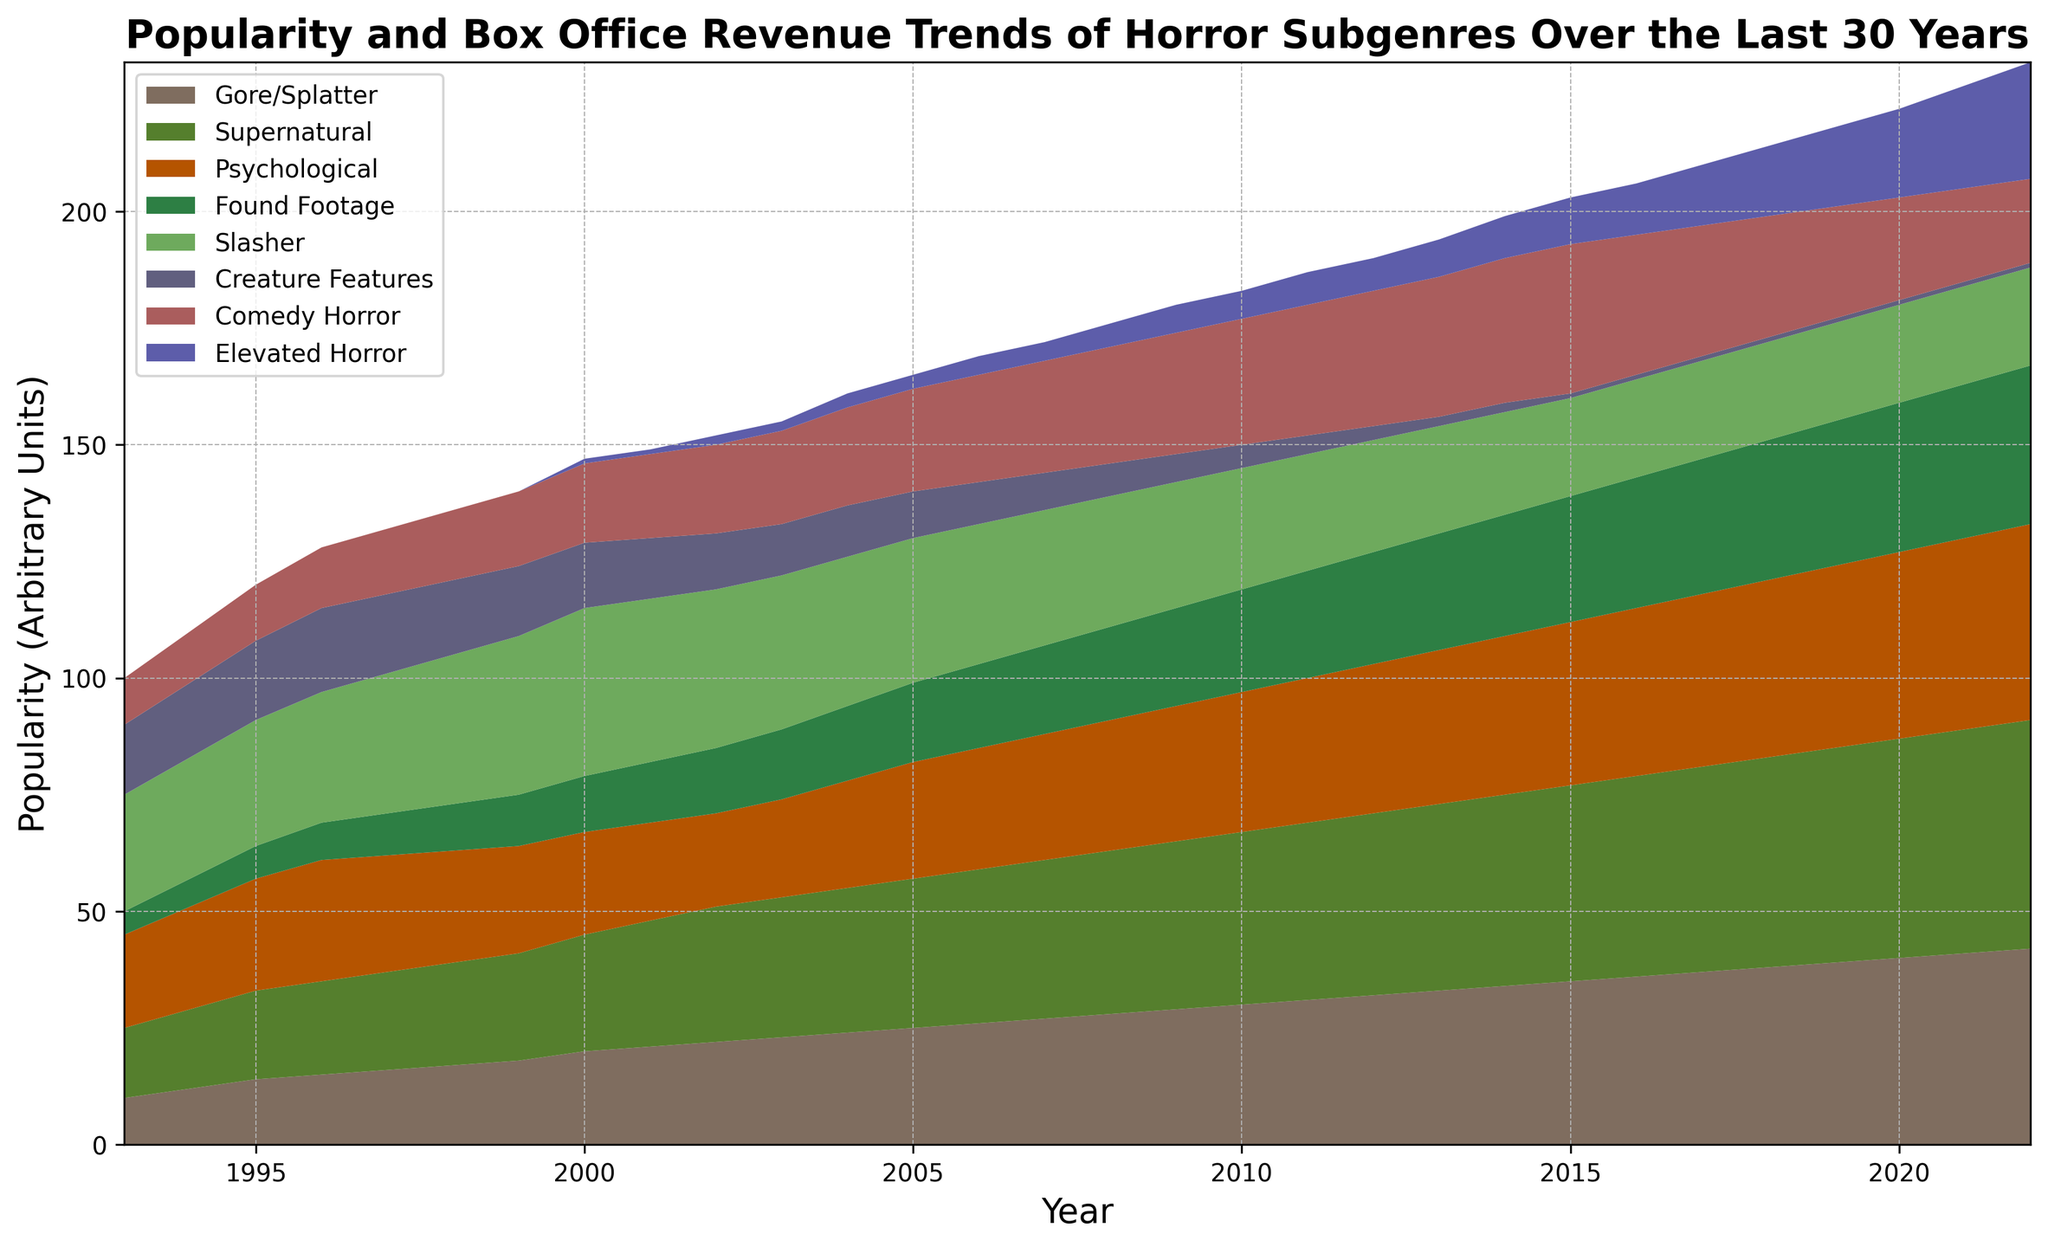How has the popularity of Elevated Horror changed from 2000 to 2022? By observing the height of the area representing Elevated Horror in 2000 and comparing it to 2022, it's clear that it started around 1 unit and increased significantly to 25 units.
Answer: Increased Which horror subgenre dominated in popularity in 1996? By examining the heights of the different colored areas at the year 1996 on the chart, the Slasher subgenre stands out with the highest value.
Answer: Slasher In which year did Comedy Horror begin to decline in popularity, and what trend followed? From visual inspection, Comedy Horror begins to decline around 2016, after witnessing a peak between 2014 and 2015. The area representing Comedy Horror repeatedly decreases after 2016.
Answer: 2016; Decline Which two subgenres had approximately equal popularity in 2022? Comparing the areas for different subgenres in 2022, Supernatural and Psychological subgenres both appear very close in height around the 49 and 42 unit marks, respectively.
Answer: Supernatural and Psychological What was the combined popularity of Found Footage and Creature Features in 2010? In 2010, the found Footage value is around 22 and Creature Features is 5. Summing these two values gives 22 + 5 = 27.
Answer: 27 Which subgenre showed the most consistent increase in popularity over the years? By observing the trends of the different subgenres, Elevated Horror shows the most consistent and steep increase from its introduction around 2000, continuously rising until 2022.
Answer: Elevated Horror How did the popularity of Slasher movies change from 1993 to 2022? From 1993 to 2022, Slasher movies remained relatively steady, peaking slightly around 2000 but overall showing a declining trend starting from the high 20s to leveling off at 21 units.
Answer: Decline Between 2000 and 2010, which subgenre saw the biggest drop in popularity? Inspecting the chart closely between these years, Creature Features show a significant drop from 14 units in 2000 to 5 units in 2010.
Answer: Creature Features Compare the popularity trend of Psychological Horror and Comedy Horror between 2005 and 2015. Visual comparison shows that Psychological Horror steadily increased from 25 to 35 units over this period, whereas Comedy Horror also saw a steady increase from 22 to 32 units. Both subgenres show an increasing trend.
Answer: Increasing trends for both 